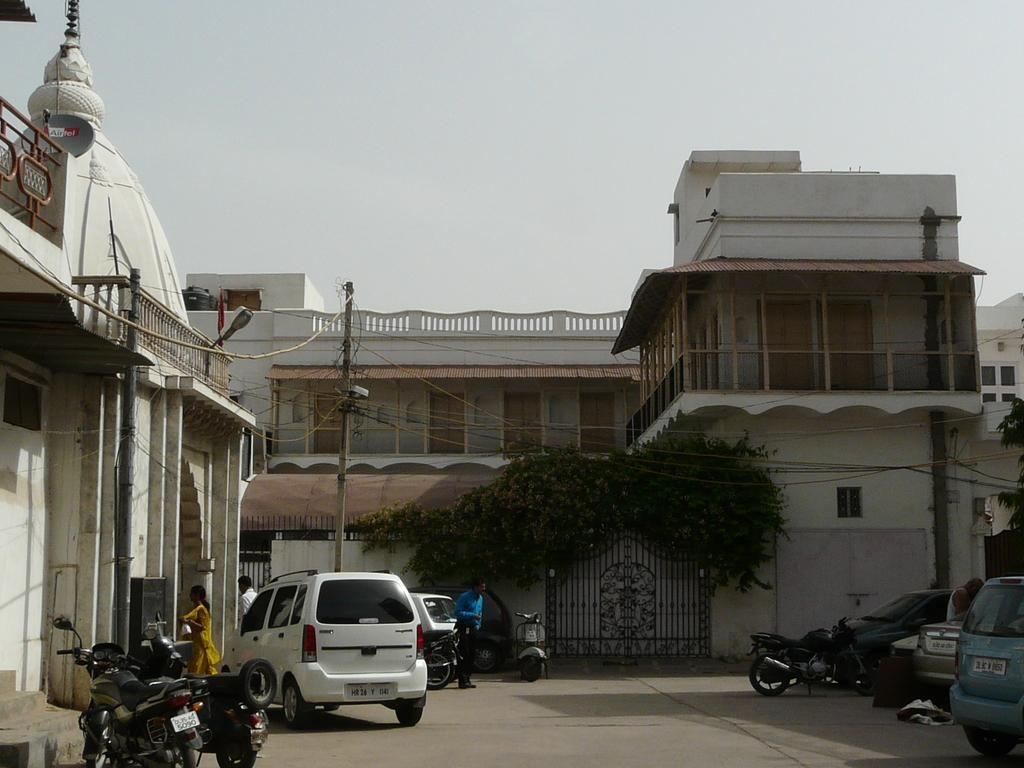Who or what can be seen in the image? There are people and vehicles in the image. What types of vehicles are present in the image? There are motorbikes in the image. Where are the motorbikes located in the image? The motorbikes are on the road. What can be seen in the background of the image? There is a pole, plants, buildings, and the sky visible in the background of the image. What type of force is being applied to the motorbikes in the image? There is no indication of any force being applied to the motorbikes in the image; they are stationary on the road. What type of team is depicted in the image? There is no team depicted in the image; it features people and vehicles in a general setting. 